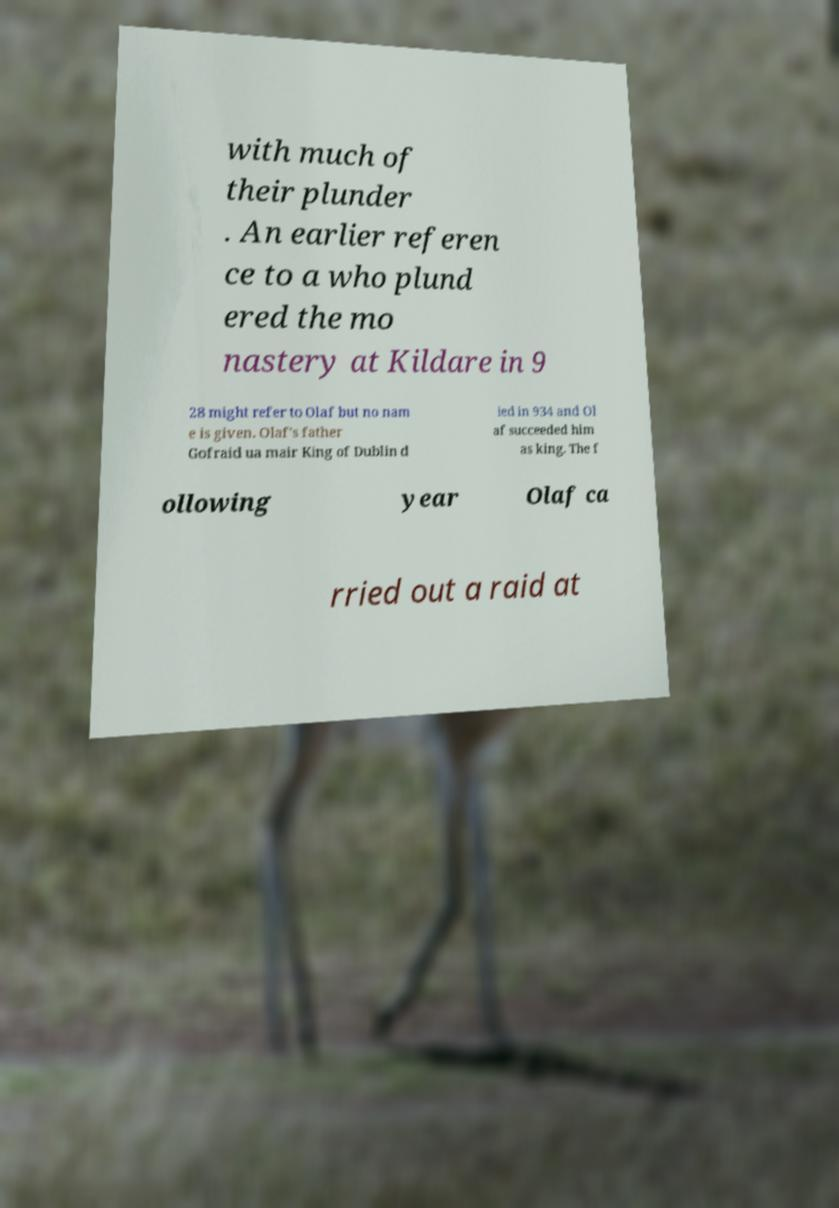Could you extract and type out the text from this image? with much of their plunder . An earlier referen ce to a who plund ered the mo nastery at Kildare in 9 28 might refer to Olaf but no nam e is given. Olaf's father Gofraid ua mair King of Dublin d ied in 934 and Ol af succeeded him as king. The f ollowing year Olaf ca rried out a raid at 